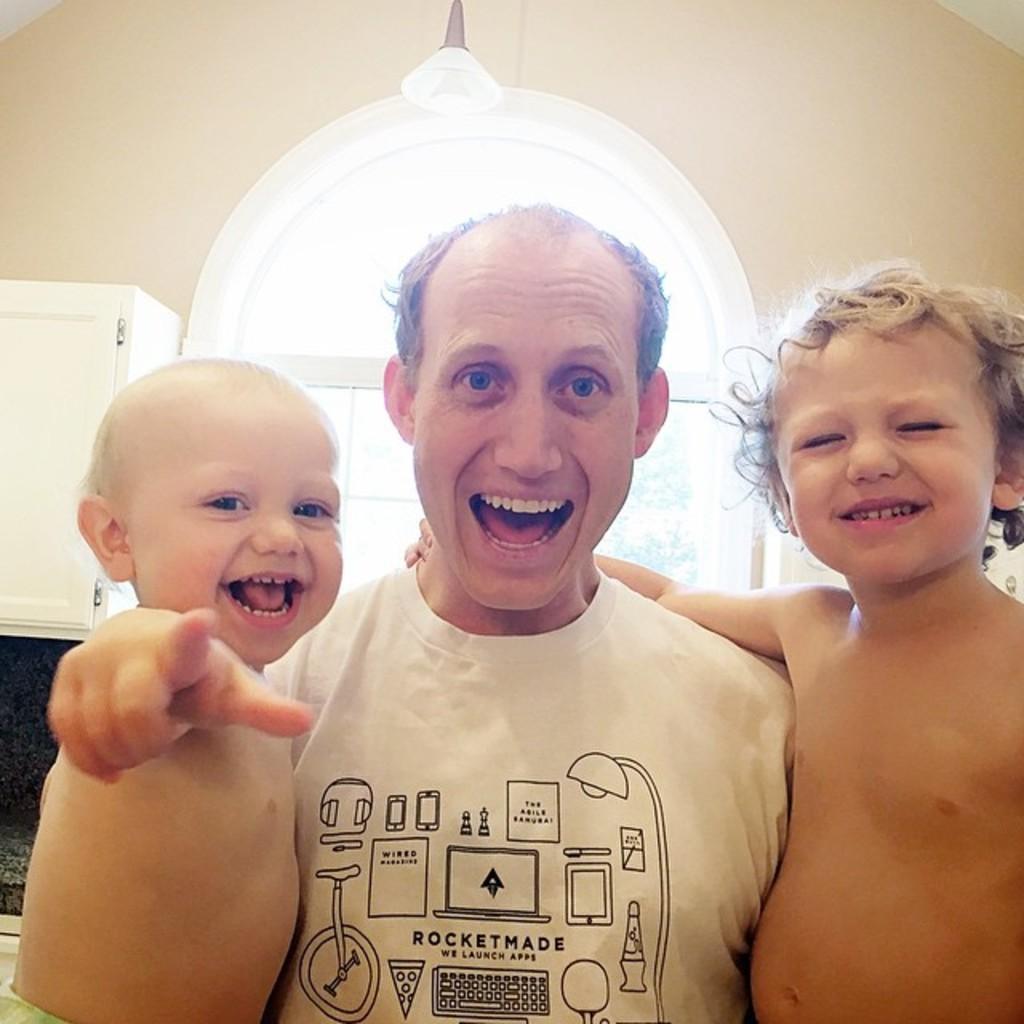Describe this image in one or two sentences. In this image I see a man and 2 babies and I see that these both of them are smiling and I see that this man is wearing a t-shirt. In the background I see the wall and I see the cupboard over here and I see the windows over here. 